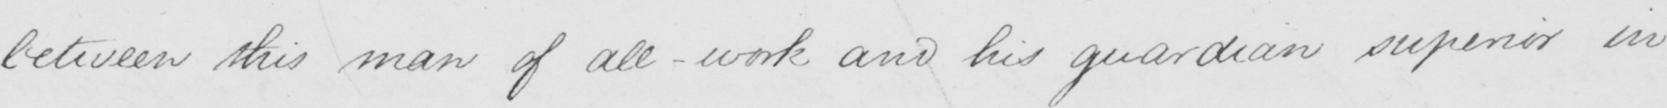What does this handwritten line say? between this man of all-work and his guardian superior in 